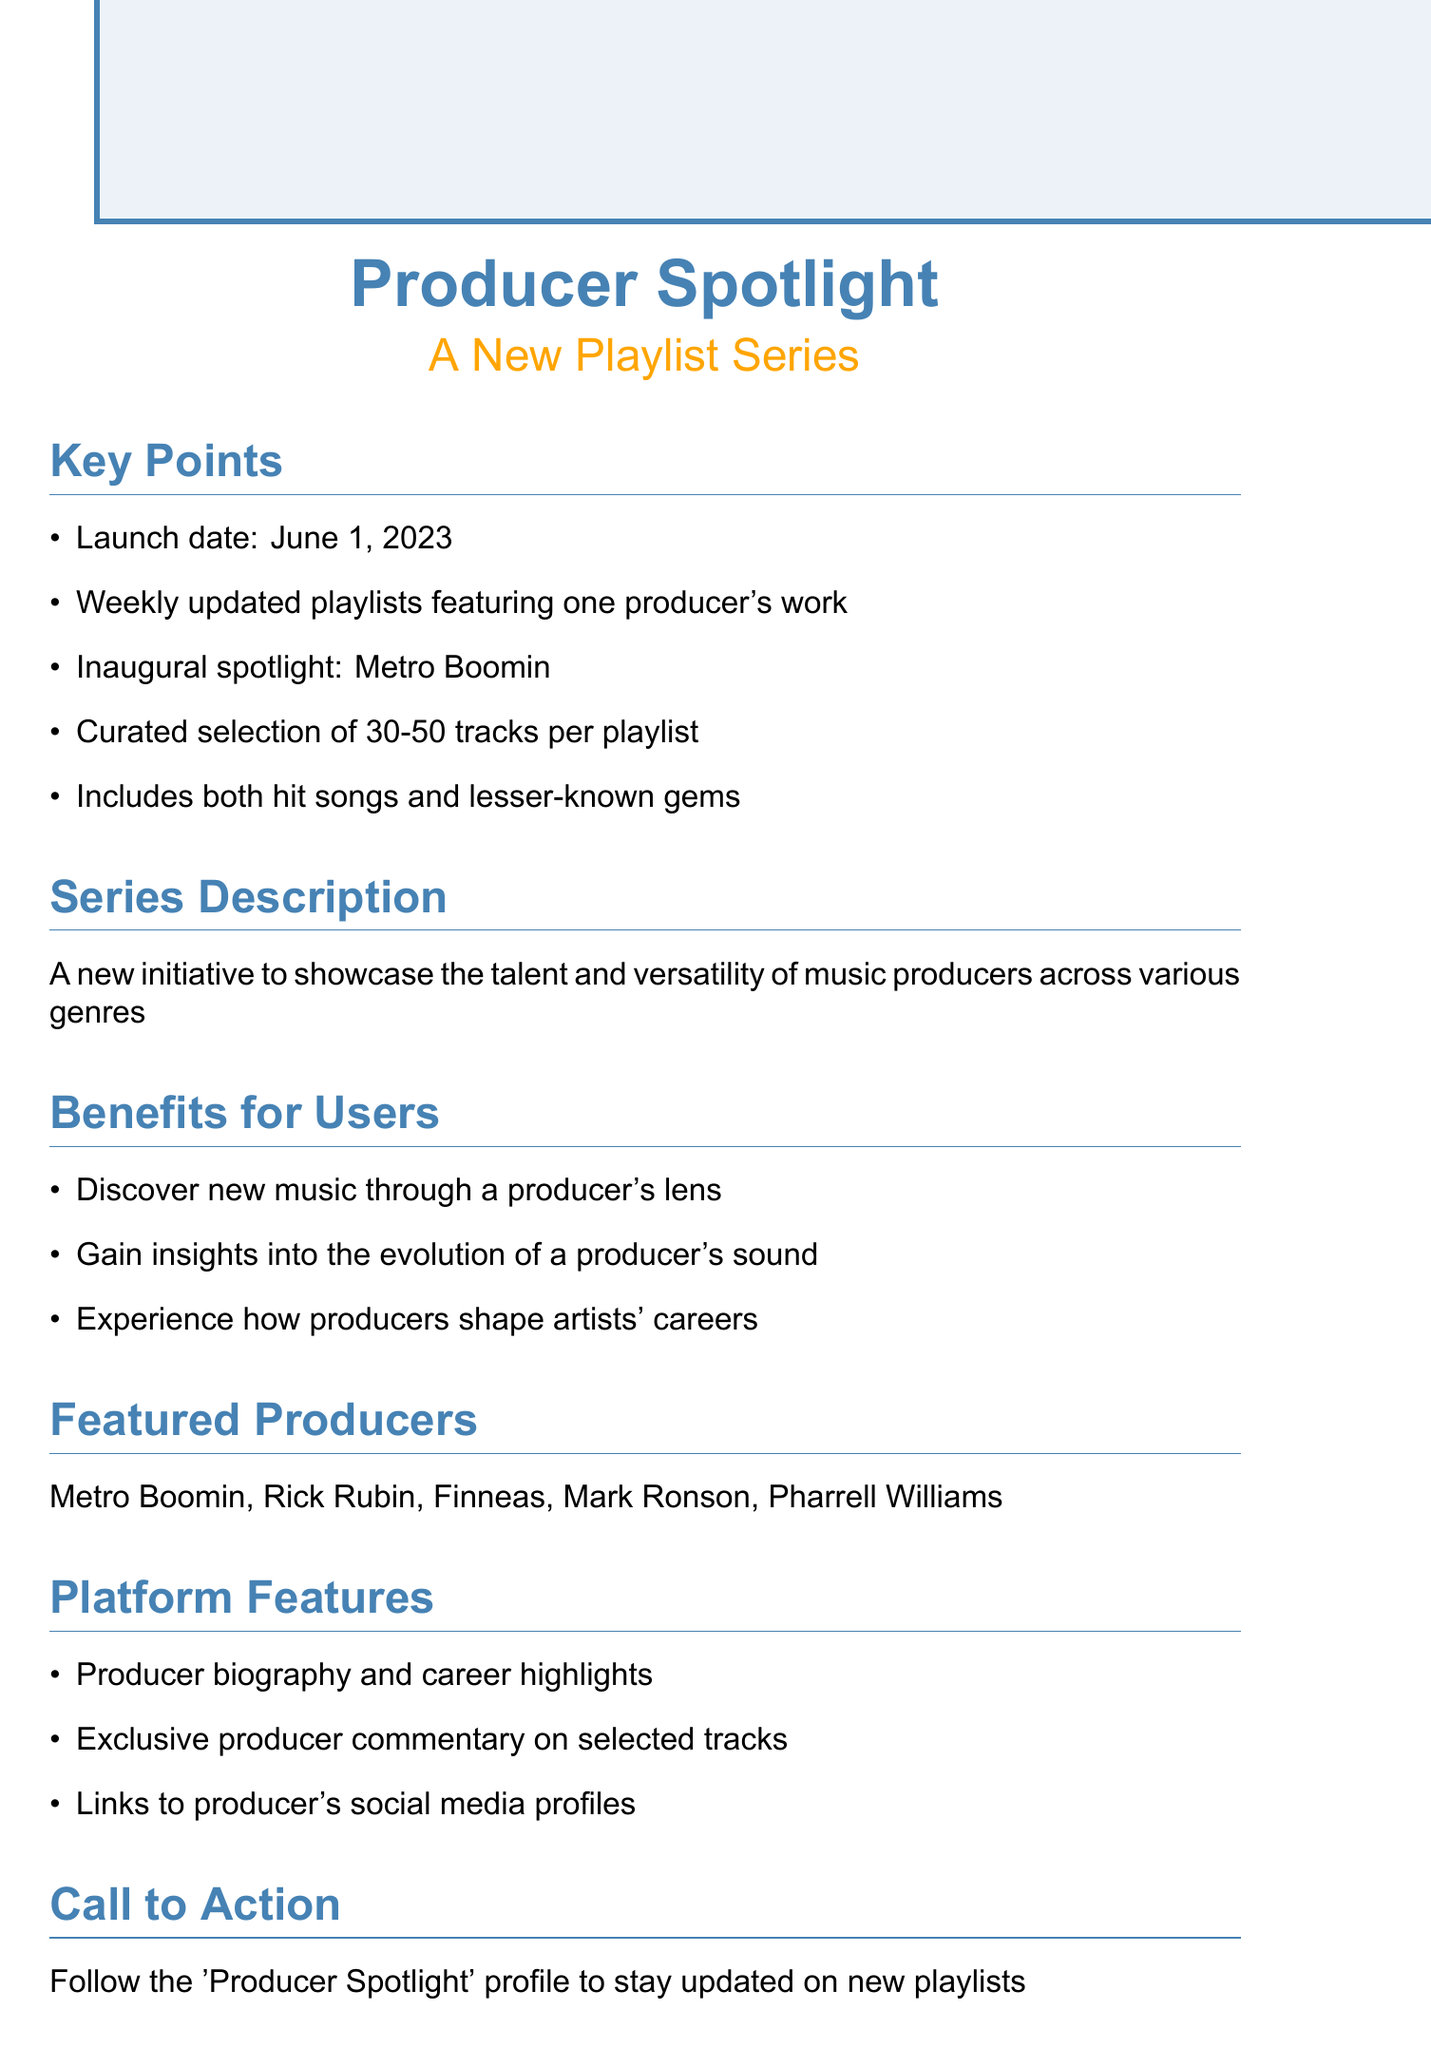What is the launch date of the playlist series? The launch date is explicitly mentioned in the document as June 1, 2023.
Answer: June 1, 2023 Who is the inaugural spotlight producer? The document specifies the inaugural spotlight as Metro Boomin.
Answer: Metro Boomin How often will the playlists be updated? The frequency of updates for the playlists is stated as weekly.
Answer: Weekly What is the range of tracks per playlist? The document provides a range for the curated selection of tracks per playlist as 30-50 tracks.
Answer: 30-50 tracks What are the benefits of the playlist for users? The document lists several benefits including discovering new music through a producer's lens.
Answer: Discover new music through a producer's lens Which producers are featured in the series? The document includes notable producers such as Metro Boomin, Rick Rubin, Finneas, Mark Ronson, and Pharrell Williams.
Answer: Metro Boomin, Rick Rubin, Finneas, Mark Ronson, Pharrell Williams What type of content will be shared on social media? The marketing strategy mentions sharing producer quotes and behind-the-scenes content on social media.
Answer: Producer quotes and behind-the-scenes content What is the call to action for users? The document encourages users to follow the 'Producer Spotlight' profile to stay updated.
Answer: Follow the 'Producer Spotlight' profile 